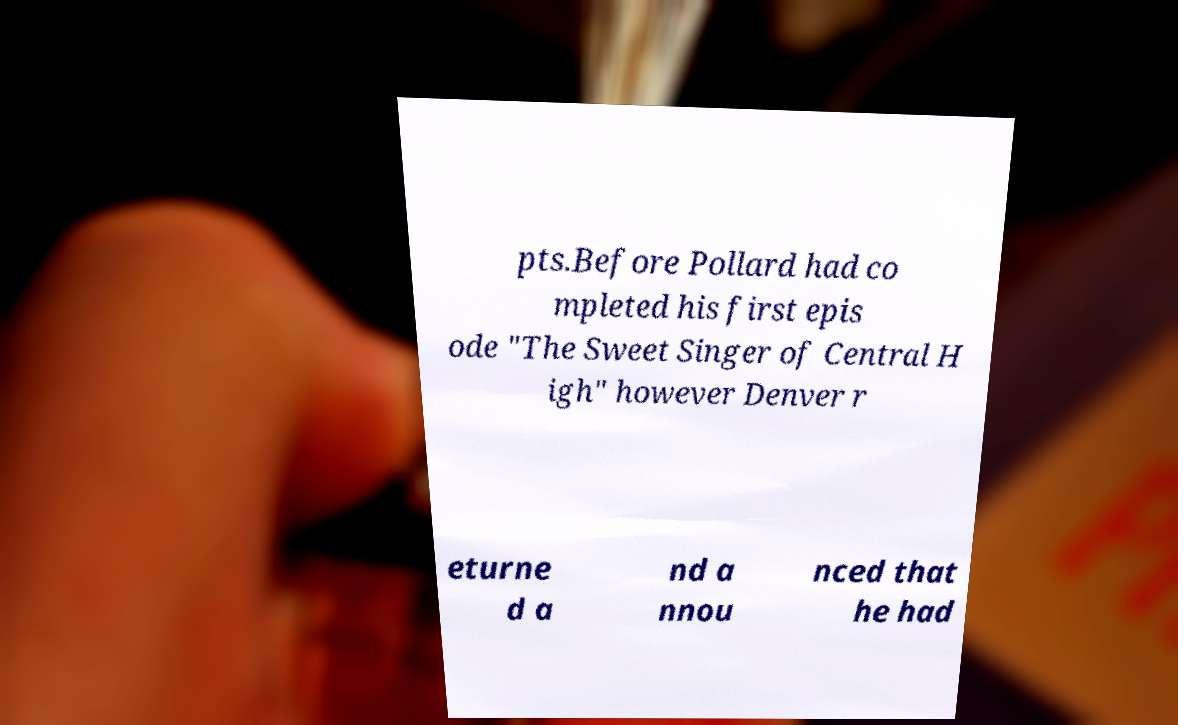Could you assist in decoding the text presented in this image and type it out clearly? pts.Before Pollard had co mpleted his first epis ode "The Sweet Singer of Central H igh" however Denver r eturne d a nd a nnou nced that he had 